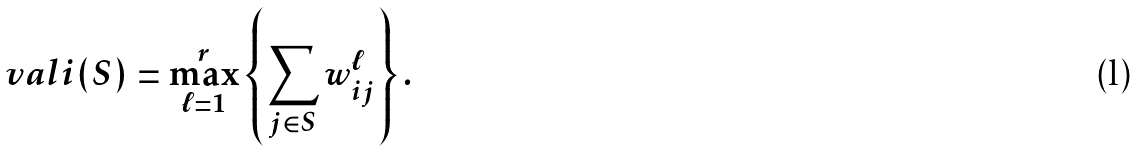Convert formula to latex. <formula><loc_0><loc_0><loc_500><loc_500>\ v a l i ( S ) = \max _ { \ell = 1 } ^ { r } \left \{ \sum _ { j \in S } w ^ { \ell } _ { i j } \right \} .</formula> 